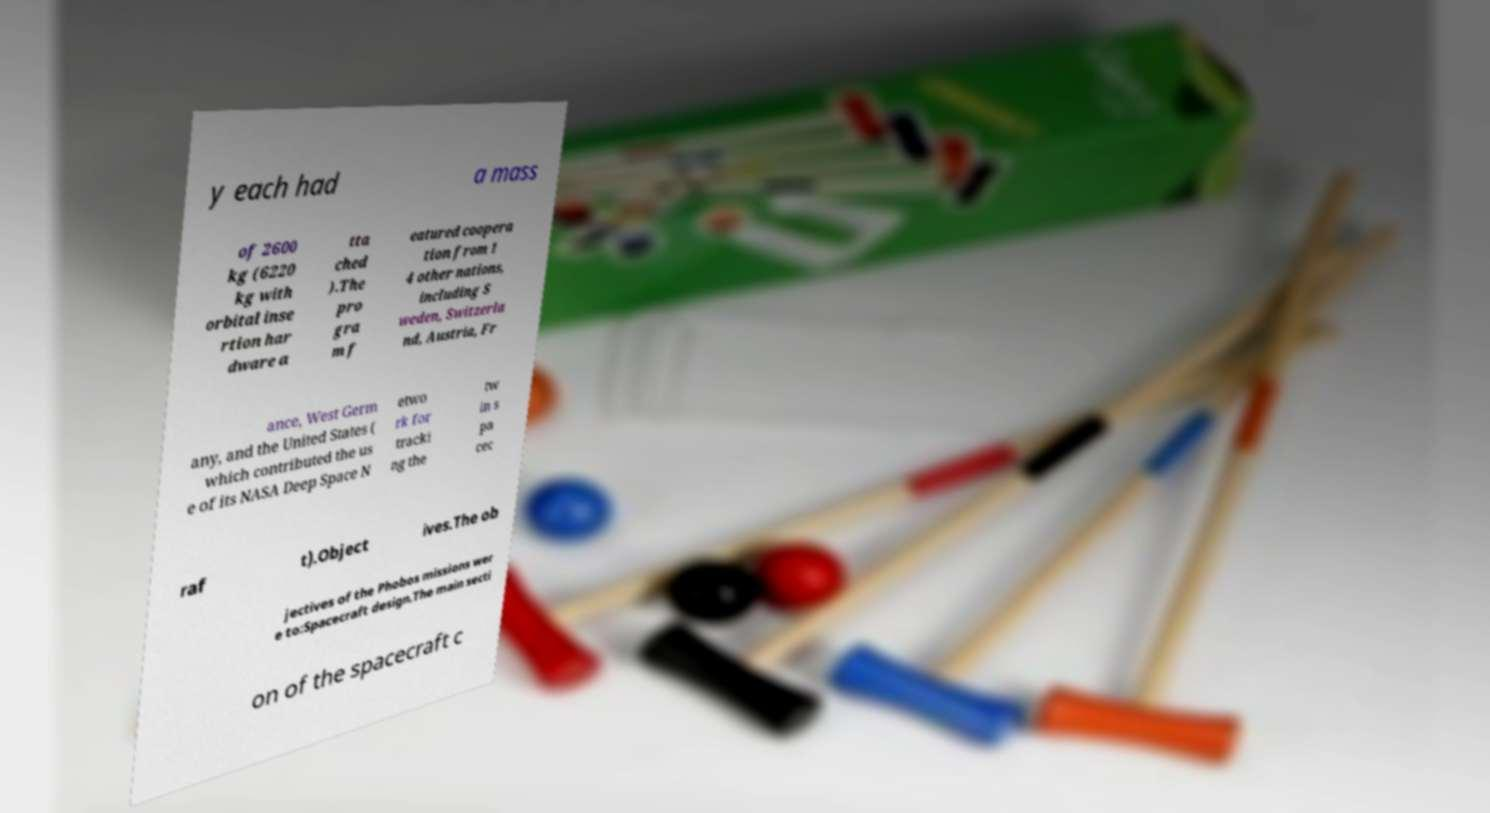Could you assist in decoding the text presented in this image and type it out clearly? y each had a mass of 2600 kg (6220 kg with orbital inse rtion har dware a tta ched ).The pro gra m f eatured coopera tion from 1 4 other nations, including S weden, Switzerla nd, Austria, Fr ance, West Germ any, and the United States ( which contributed the us e of its NASA Deep Space N etwo rk for tracki ng the tw in s pa cec raf t).Object ives.The ob jectives of the Phobos missions wer e to:Spacecraft design.The main secti on of the spacecraft c 